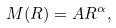Convert formula to latex. <formula><loc_0><loc_0><loc_500><loc_500>M ( R ) = A R ^ { \alpha } ,</formula> 